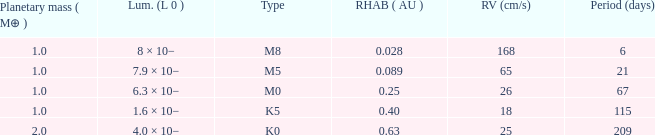What is the total stellar mass of the type m0? 0.47. 